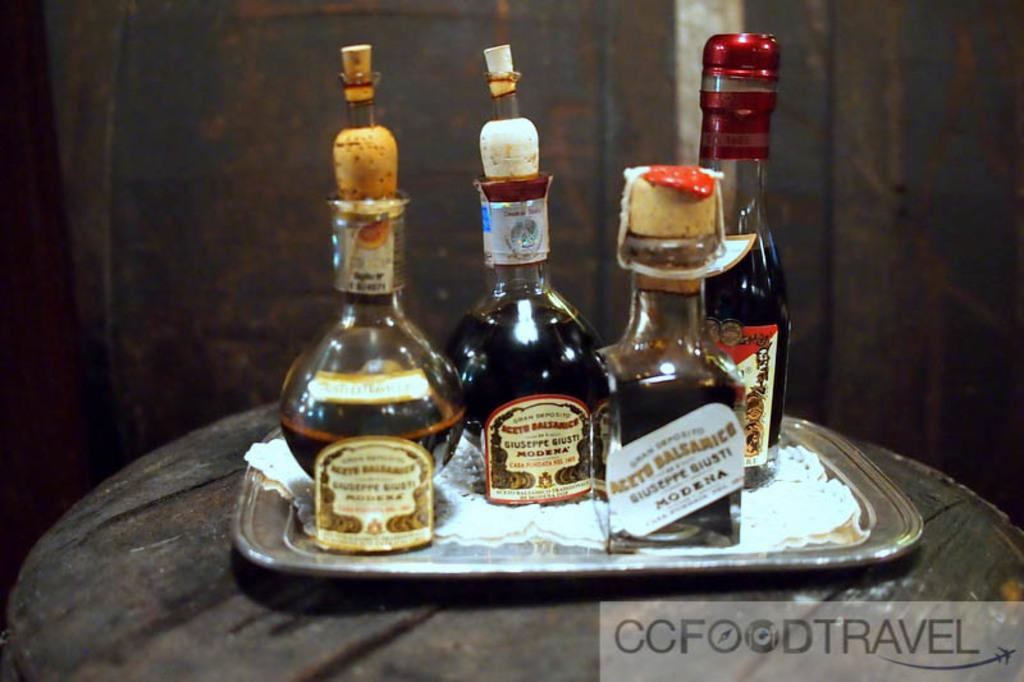<image>
Create a compact narrative representing the image presented. Various small bottle of Modena alcohol for CCFoodTravel. 